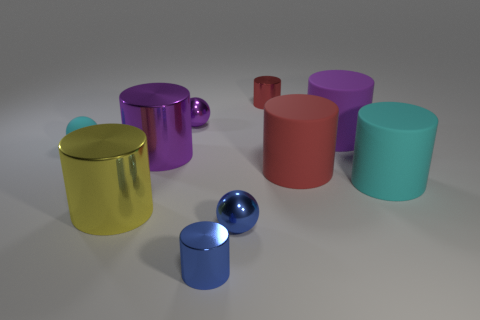How many other objects are there of the same shape as the large red rubber thing? There are a total of five objects that share the same cylindrical shape as the large red one. This includes cylinders of different colors and sizes but does not include any spheres or objects of other shapes. 